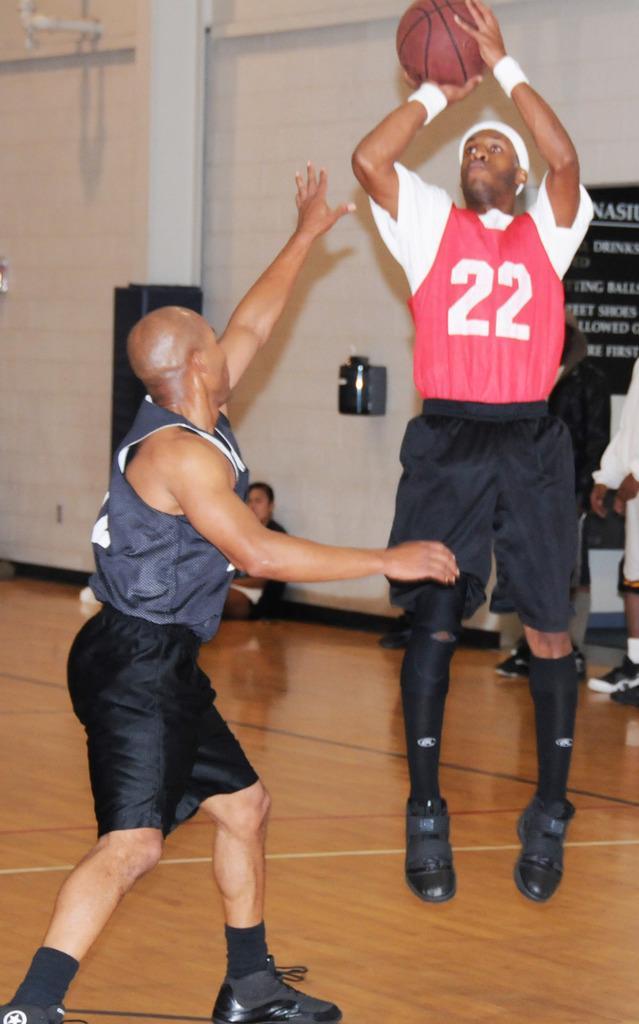Could you give a brief overview of what you see in this image? In this picture there is a man on the right side of the image, by holding a ball in his hands, it seems to be, he is jumping and there is another man beside him, there are other people, pillar and a board in the background area of the image. 